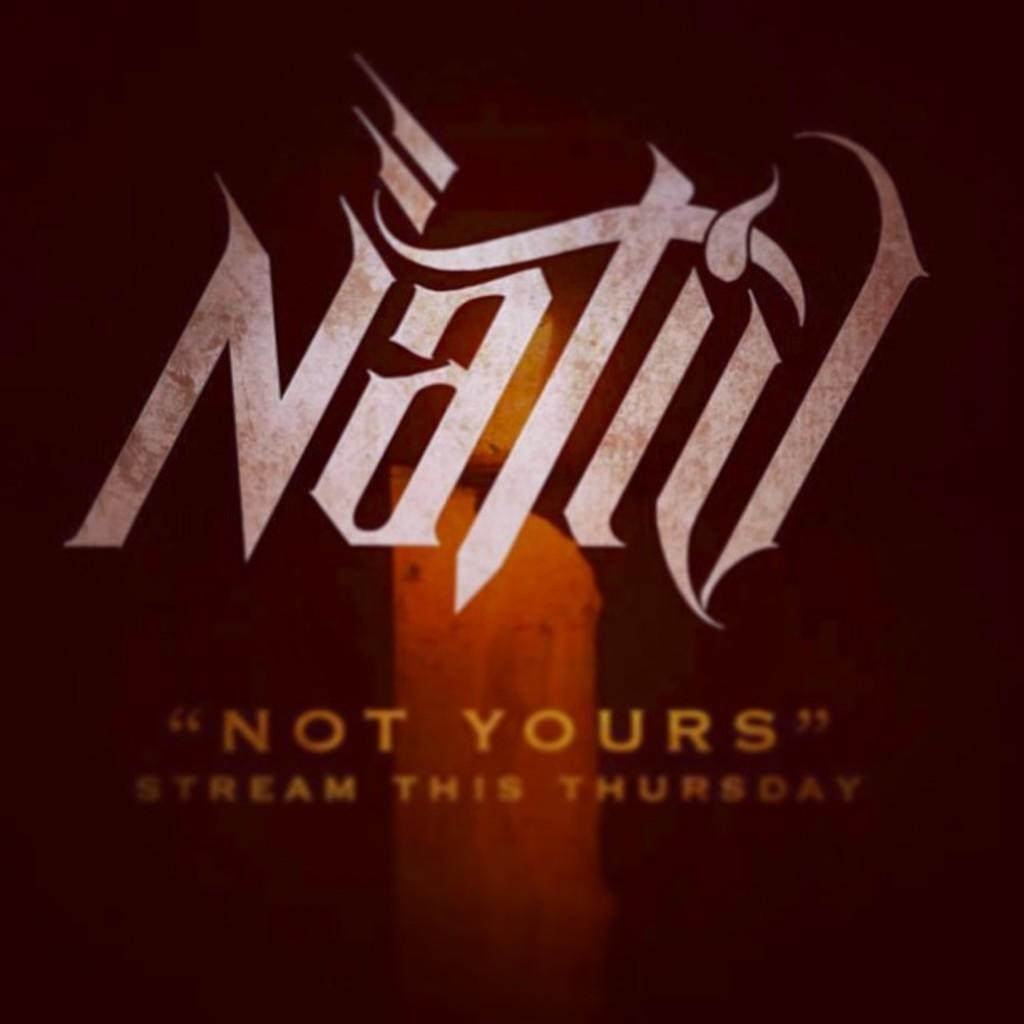<image>
Summarize the visual content of the image. Nativ Not yours streams this thrudsday brown background with a candle in the center 